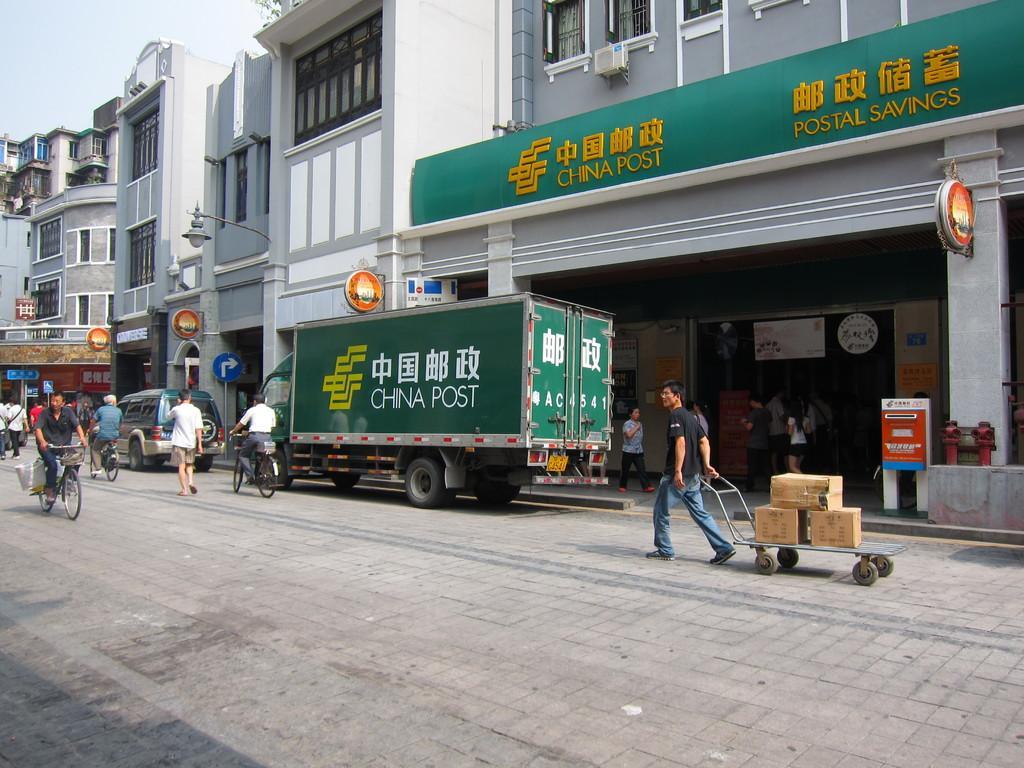In one or two sentences, can you explain what this image depicts? In this picture there is a man who is wearing t-shirt, spectacle, jeans and shoe. He is holding a trolley. On the trolley we can see the cotton boxers. In-front of him there is a truck which is parked near to the building, beside the truck we can see two persons were riding a bicycle. On the left there is a car which is parked near to the sign boards. In the top left corner we can see sky and tree. 